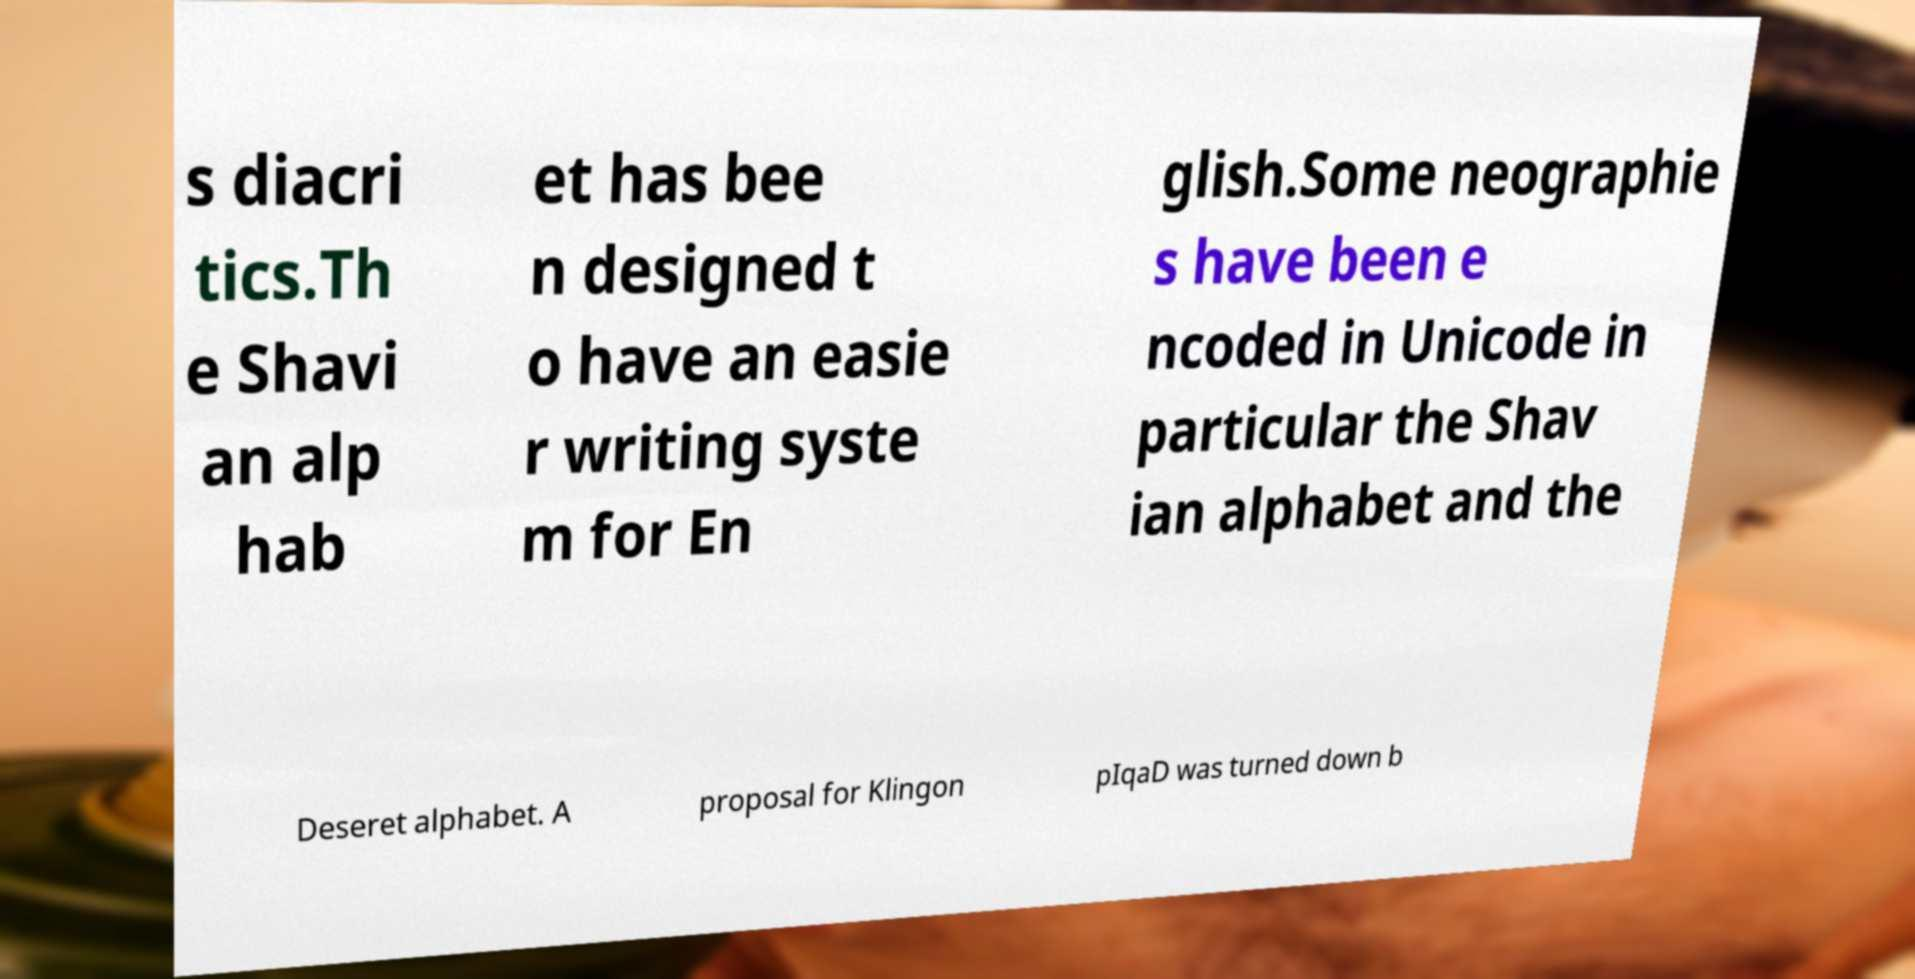Could you extract and type out the text from this image? s diacri tics.Th e Shavi an alp hab et has bee n designed t o have an easie r writing syste m for En glish.Some neographie s have been e ncoded in Unicode in particular the Shav ian alphabet and the Deseret alphabet. A proposal for Klingon pIqaD was turned down b 